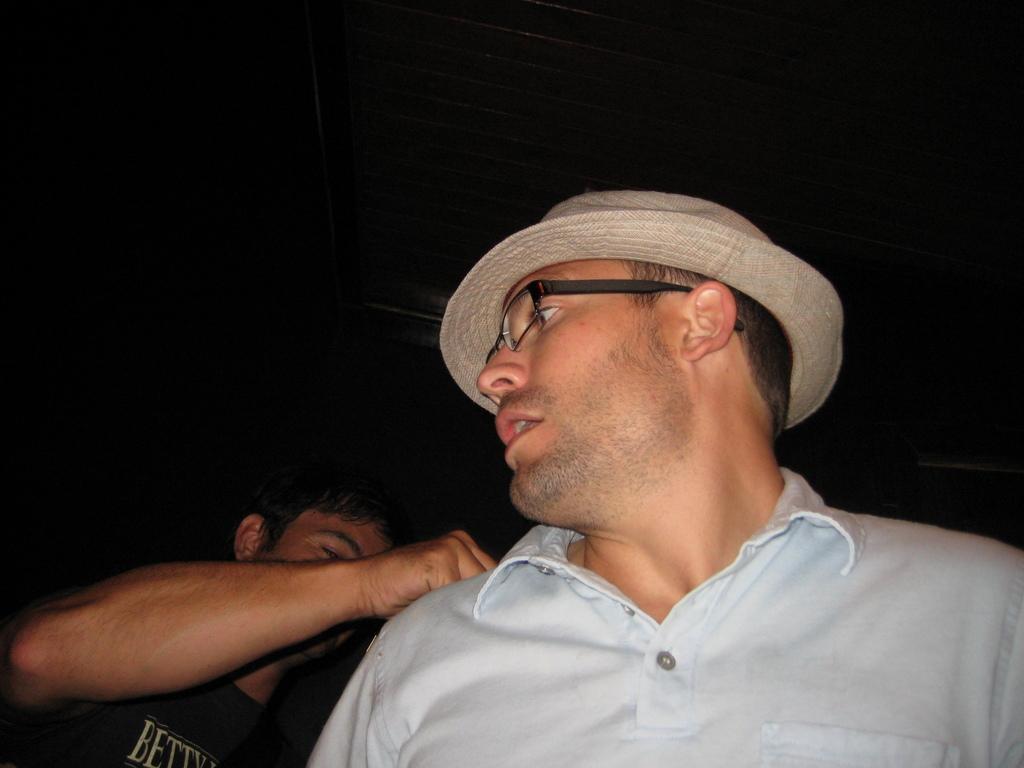How would you summarize this image in a sentence or two? In this image we can see a person wearing the glasses and also the hat. On the left there is also another person and the background is in black color. 